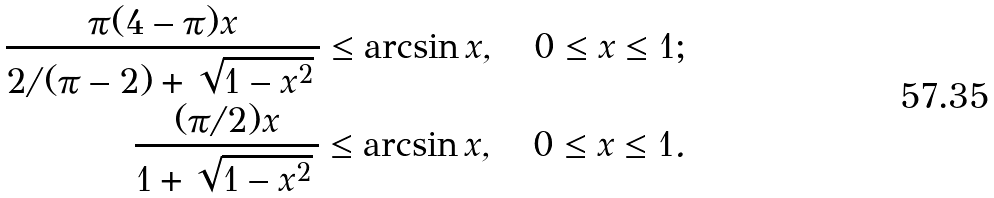Convert formula to latex. <formula><loc_0><loc_0><loc_500><loc_500>\frac { \pi ( 4 - \pi ) x } { 2 / ( \pi - 2 ) + \sqrt { 1 - x ^ { 2 } } \, } \leq \arcsin x , \quad 0 \leq x \leq 1 ; \\ \frac { ( \pi / 2 ) x } { 1 + \sqrt { 1 - x ^ { 2 } } \, } \leq \arcsin x , \quad 0 \leq x \leq 1 .</formula> 